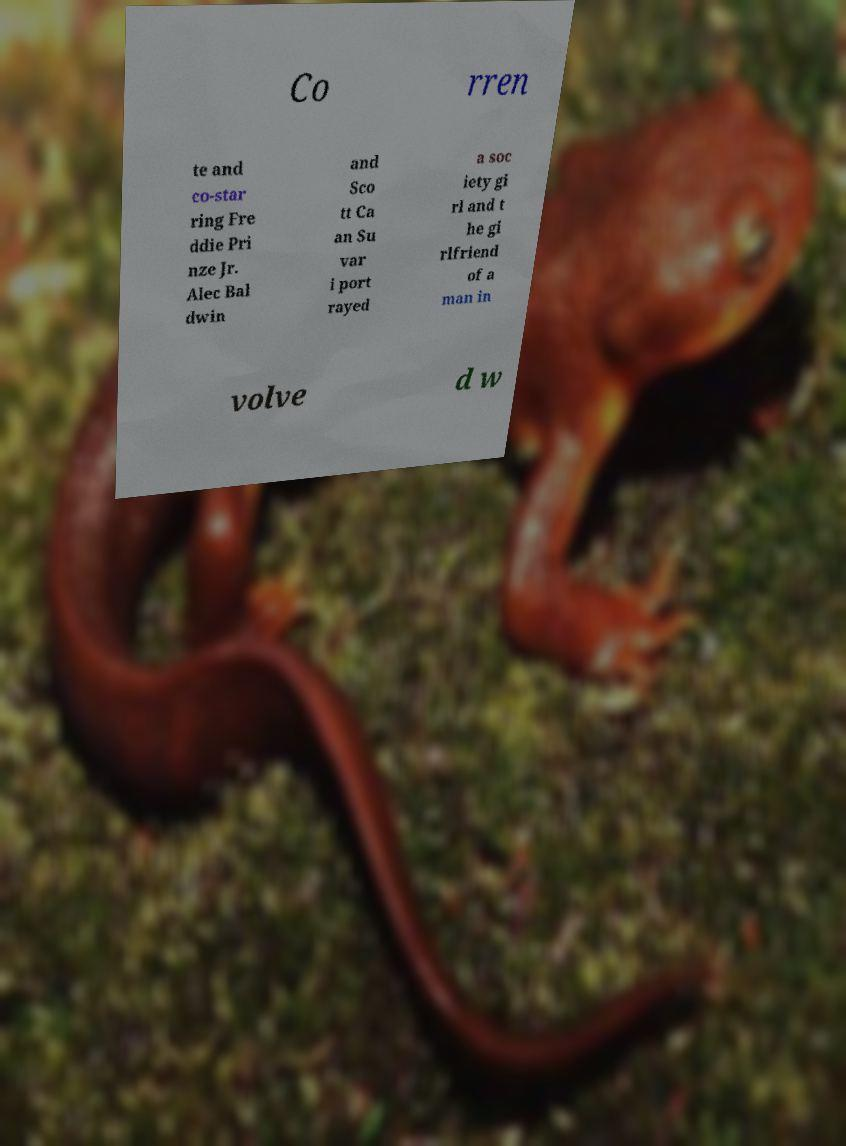Could you extract and type out the text from this image? Co rren te and co-star ring Fre ddie Pri nze Jr. Alec Bal dwin and Sco tt Ca an Su var i port rayed a soc iety gi rl and t he gi rlfriend of a man in volve d w 